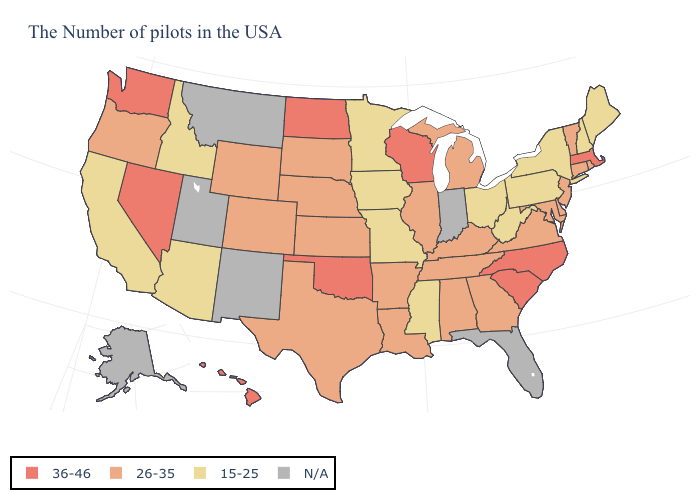What is the highest value in states that border Alabama?
Short answer required. 26-35. What is the value of New Jersey?
Keep it brief. 26-35. Which states have the lowest value in the USA?
Concise answer only. Maine, New Hampshire, New York, Pennsylvania, West Virginia, Ohio, Mississippi, Missouri, Minnesota, Iowa, Arizona, Idaho, California. Among the states that border Delaware , which have the highest value?
Write a very short answer. New Jersey, Maryland. What is the lowest value in states that border Michigan?
Short answer required. 15-25. What is the lowest value in the USA?
Quick response, please. 15-25. What is the value of Iowa?
Short answer required. 15-25. Does the map have missing data?
Keep it brief. Yes. What is the value of New Mexico?
Keep it brief. N/A. Name the states that have a value in the range 26-35?
Concise answer only. Rhode Island, Vermont, Connecticut, New Jersey, Delaware, Maryland, Virginia, Georgia, Michigan, Kentucky, Alabama, Tennessee, Illinois, Louisiana, Arkansas, Kansas, Nebraska, Texas, South Dakota, Wyoming, Colorado, Oregon. Which states hav the highest value in the Northeast?
Quick response, please. Massachusetts. What is the highest value in states that border Virginia?
Short answer required. 36-46. Does Virginia have the lowest value in the South?
Keep it brief. No. What is the value of Virginia?
Keep it brief. 26-35. Does the map have missing data?
Write a very short answer. Yes. 